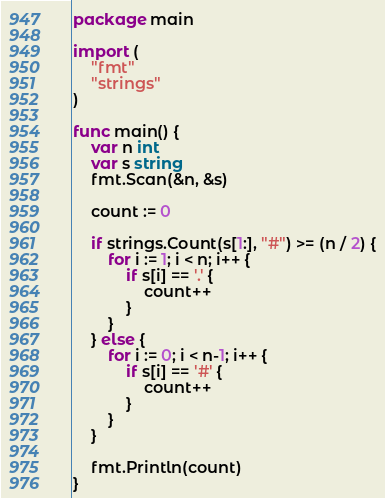<code> <loc_0><loc_0><loc_500><loc_500><_Go_>package main

import (
	"fmt"
	"strings"
)

func main() {
	var n int
	var s string
	fmt.Scan(&n, &s)

	count := 0

	if strings.Count(s[1:], "#") >= (n / 2) {
		for i := 1; i < n; i++ {
			if s[i] == '.' {
				count++
			}
		}
	} else {
		for i := 0; i < n-1; i++ {
			if s[i] == '#' {
				count++
			}
		}
	}

	fmt.Println(count)
}
</code> 